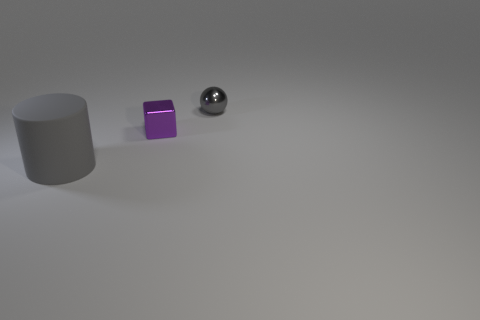There is a small thing that is the same material as the small cube; what color is it?
Your answer should be compact. Gray. Are there fewer blue objects than gray spheres?
Offer a terse response. Yes. The thing that is left of the tiny shiny sphere and behind the gray matte thing is made of what material?
Your answer should be compact. Metal. There is a metal object that is behind the purple metallic thing; are there any metal objects that are in front of it?
Make the answer very short. Yes. How many shiny things have the same color as the big rubber cylinder?
Offer a very short reply. 1. What is the material of the small thing that is the same color as the rubber cylinder?
Make the answer very short. Metal. Are the large gray object and the purple object made of the same material?
Make the answer very short. No. There is a gray matte cylinder; are there any purple metal cubes to the right of it?
Your answer should be very brief. Yes. There is a gray thing that is on the left side of the shiny thing behind the small metallic cube; what is it made of?
Make the answer very short. Rubber. Is the rubber cylinder the same color as the ball?
Provide a short and direct response. Yes. 